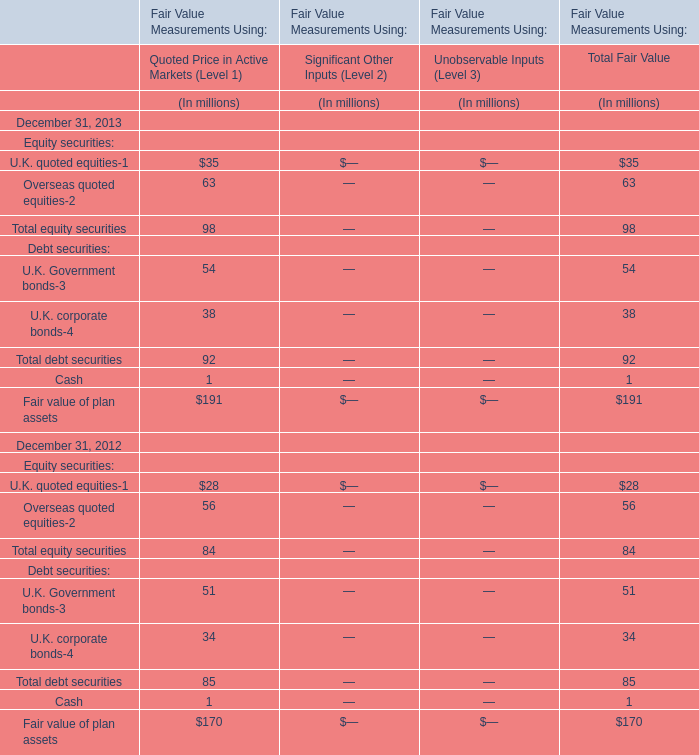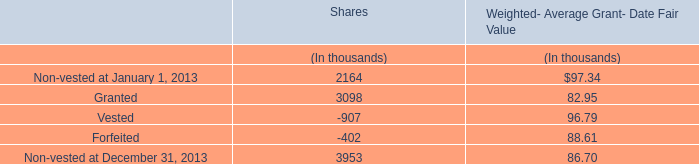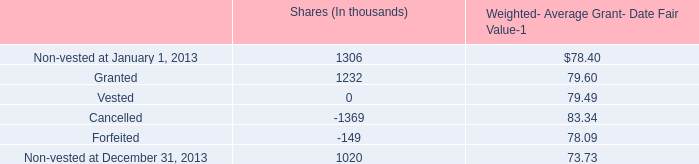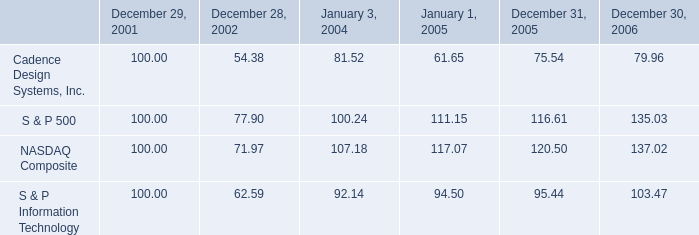What's the total amount of U.K. quoted equities, Overseas quoted equities, U.K. Government bonds and U.K. corporate bonds in Quoted Price in Active Markets (Level 1) in 2013? (in millions) 
Computations: (((35 + 63) + 54) + 38)
Answer: 190.0. 